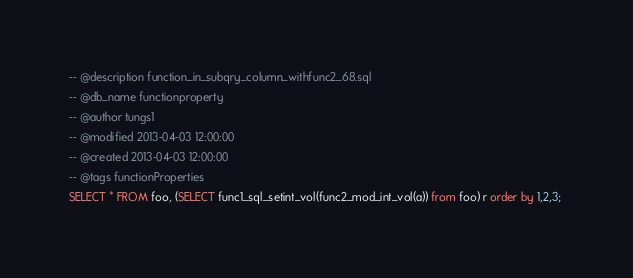<code> <loc_0><loc_0><loc_500><loc_500><_SQL_>-- @description function_in_subqry_column_withfunc2_68.sql
-- @db_name functionproperty
-- @author tungs1
-- @modified 2013-04-03 12:00:00
-- @created 2013-04-03 12:00:00
-- @tags functionProperties 
SELECT * FROM foo, (SELECT func1_sql_setint_vol(func2_mod_int_vol(a)) from foo) r order by 1,2,3; 
</code> 